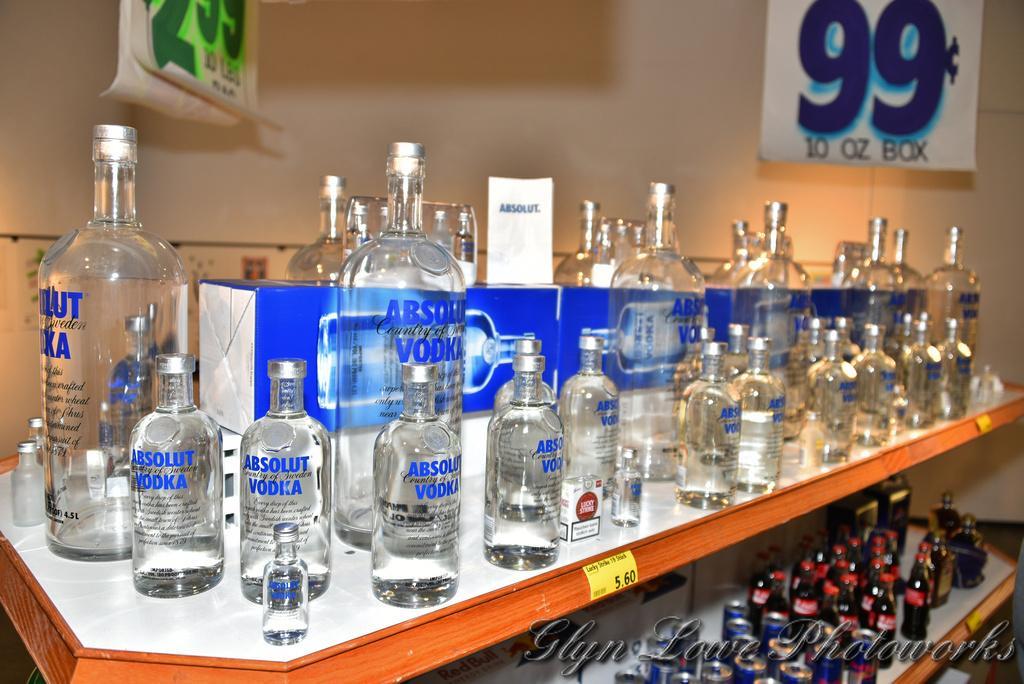In one or two sentences, can you explain what this image depicts? In this image i can see glass bottles in a shelf and in the background i can see a wall and few banners. 